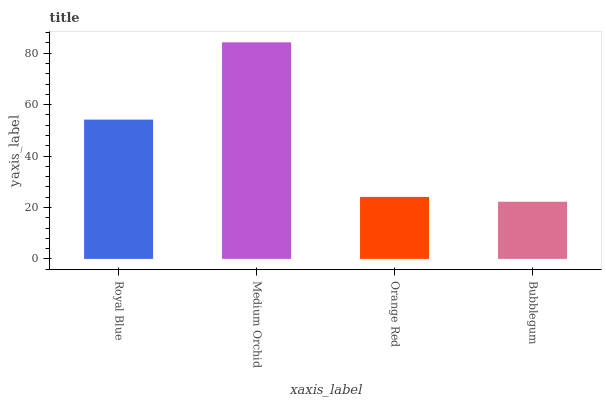Is Orange Red the minimum?
Answer yes or no. No. Is Orange Red the maximum?
Answer yes or no. No. Is Medium Orchid greater than Orange Red?
Answer yes or no. Yes. Is Orange Red less than Medium Orchid?
Answer yes or no. Yes. Is Orange Red greater than Medium Orchid?
Answer yes or no. No. Is Medium Orchid less than Orange Red?
Answer yes or no. No. Is Royal Blue the high median?
Answer yes or no. Yes. Is Orange Red the low median?
Answer yes or no. Yes. Is Orange Red the high median?
Answer yes or no. No. Is Bubblegum the low median?
Answer yes or no. No. 